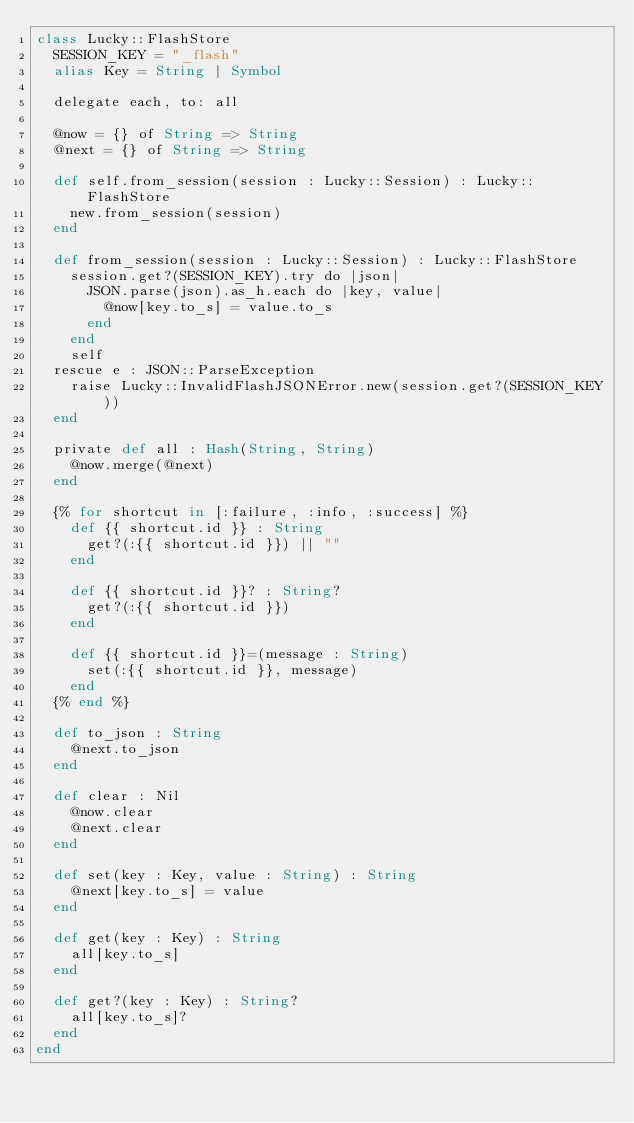<code> <loc_0><loc_0><loc_500><loc_500><_Crystal_>class Lucky::FlashStore
  SESSION_KEY = "_flash"
  alias Key = String | Symbol

  delegate each, to: all

  @now = {} of String => String
  @next = {} of String => String

  def self.from_session(session : Lucky::Session) : Lucky::FlashStore
    new.from_session(session)
  end

  def from_session(session : Lucky::Session) : Lucky::FlashStore
    session.get?(SESSION_KEY).try do |json|
      JSON.parse(json).as_h.each do |key, value|
        @now[key.to_s] = value.to_s
      end
    end
    self
  rescue e : JSON::ParseException
    raise Lucky::InvalidFlashJSONError.new(session.get?(SESSION_KEY))
  end

  private def all : Hash(String, String)
    @now.merge(@next)
  end

  {% for shortcut in [:failure, :info, :success] %}
    def {{ shortcut.id }} : String
      get?(:{{ shortcut.id }}) || ""
    end

    def {{ shortcut.id }}? : String?
      get?(:{{ shortcut.id }})
    end

    def {{ shortcut.id }}=(message : String)
      set(:{{ shortcut.id }}, message)
    end
  {% end %}

  def to_json : String
    @next.to_json
  end

  def clear : Nil
    @now.clear
    @next.clear
  end

  def set(key : Key, value : String) : String
    @next[key.to_s] = value
  end

  def get(key : Key) : String
    all[key.to_s]
  end

  def get?(key : Key) : String?
    all[key.to_s]?
  end
end
</code> 